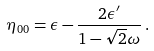Convert formula to latex. <formula><loc_0><loc_0><loc_500><loc_500>\eta _ { 0 0 } = \epsilon - \frac { 2 \epsilon ^ { \prime } } { 1 - \sqrt { 2 } \omega } \, .</formula> 